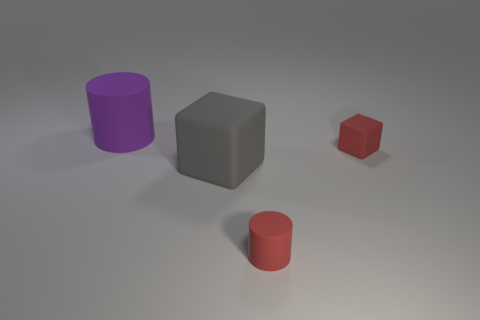Is the material of the gray block the same as the purple object?
Your answer should be compact. Yes. The rubber thing that is the same color as the tiny cylinder is what shape?
Provide a short and direct response. Cube. Is the color of the large matte cylinder that is left of the red cube the same as the large rubber cube?
Your answer should be compact. No. There is a cylinder that is right of the gray matte cube; what number of large purple rubber cylinders are in front of it?
Your response must be concise. 0. The rubber block that is the same size as the purple matte thing is what color?
Provide a succinct answer. Gray. There is a cylinder that is to the right of the large purple cylinder; what is its material?
Ensure brevity in your answer.  Rubber. There is a object that is behind the tiny red cylinder and in front of the small matte block; what material is it?
Ensure brevity in your answer.  Rubber. There is a rubber object in front of the gray rubber object; is it the same size as the large cylinder?
Make the answer very short. No. The large gray matte object is what shape?
Keep it short and to the point. Cube. What number of other big purple matte objects have the same shape as the large purple rubber thing?
Keep it short and to the point. 0. 